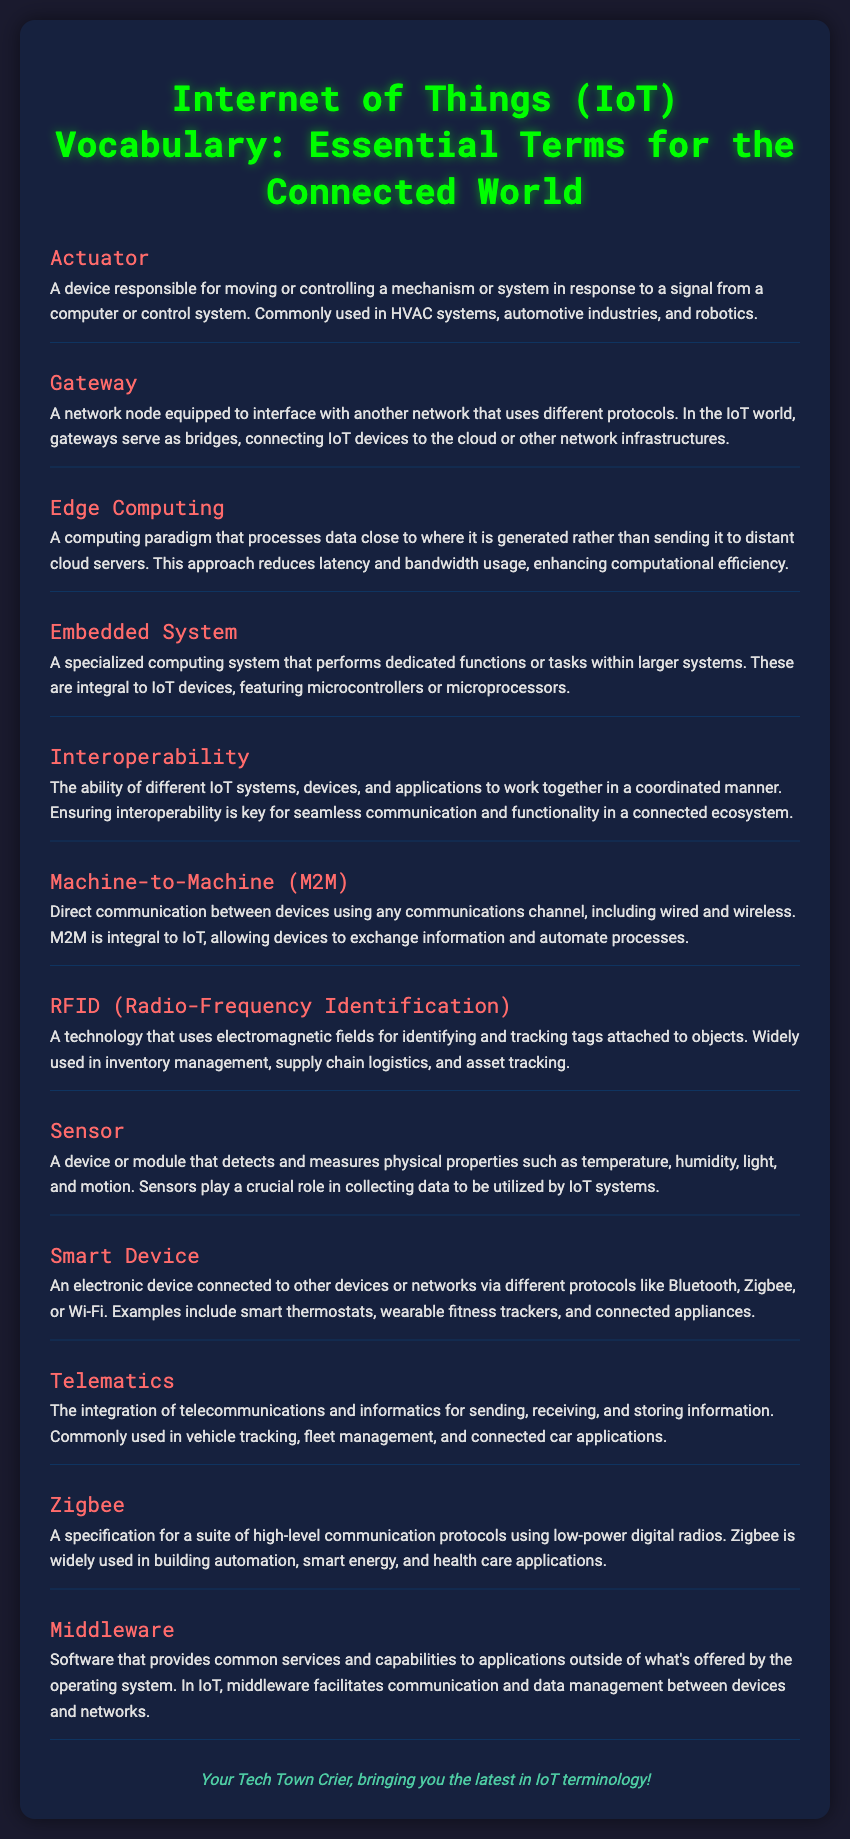What is an actuator? The document defines an actuator as a device responsible for moving or controlling a mechanism or system in response to a signal from a computer or control system.
Answer: A device responsible for moving or controlling a mechanism What does a gateway do in IoT? According to the document, a gateway serves as a bridge, connecting IoT devices to the cloud or other network infrastructures.
Answer: Connects IoT devices to the cloud What is edge computing? Edge computing is defined in the document as a computing paradigm that processes data close to where it is generated, reducing latency and bandwidth usage.
Answer: A computing paradigm that processes data close to where it is generated What is the purpose of a sensor? The document describes the purpose of a sensor as a device that detects and measures physical properties, playing a crucial role in collecting data for IoT systems.
Answer: Detects and measures physical properties How does interoperability benefit IoT systems? The document states that interoperability allows different IoT systems, devices, and applications to work together in a coordinated manner, enhancing communication.
Answer: Ensures seamless communication What technology is used for identifying and tracking objects? The document mentions RFID as a technology used for identifying and tracking tags attached to objects.
Answer: RFID (Radio-Frequency Identification) What type of protocol does Zigbee use? According to the document, Zigbee uses high-level communication protocols based on low-power digital radios.
Answer: Low-power digital radios What role does middleware play in IoT? Middleware is defined in the document as software that facilitates communication and data management between devices and networks.
Answer: Facilitates communication and data management 